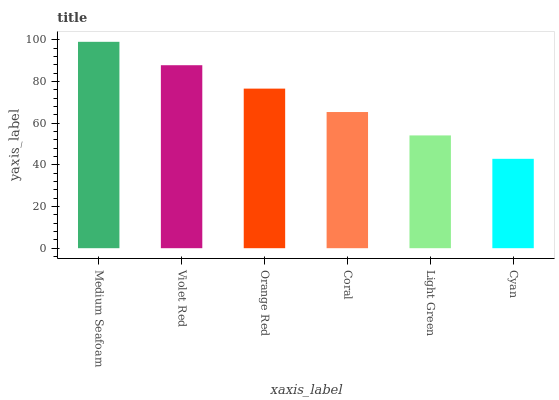Is Violet Red the minimum?
Answer yes or no. No. Is Violet Red the maximum?
Answer yes or no. No. Is Medium Seafoam greater than Violet Red?
Answer yes or no. Yes. Is Violet Red less than Medium Seafoam?
Answer yes or no. Yes. Is Violet Red greater than Medium Seafoam?
Answer yes or no. No. Is Medium Seafoam less than Violet Red?
Answer yes or no. No. Is Orange Red the high median?
Answer yes or no. Yes. Is Coral the low median?
Answer yes or no. Yes. Is Cyan the high median?
Answer yes or no. No. Is Violet Red the low median?
Answer yes or no. No. 